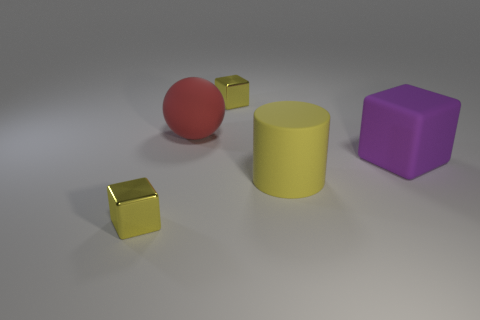Is the tiny yellow object that is behind the big yellow rubber thing made of the same material as the cylinder?
Offer a very short reply. No. How big is the ball that is behind the big purple matte block?
Make the answer very short. Large. There is a tiny metal block that is in front of the large red matte thing; is there a tiny metal cube that is to the right of it?
Keep it short and to the point. Yes. There is a small metal thing in front of the large red rubber thing; does it have the same color as the metallic object that is behind the purple object?
Give a very brief answer. Yes. The rubber cylinder has what color?
Offer a very short reply. Yellow. Is there any other thing that has the same color as the matte cylinder?
Provide a short and direct response. Yes. There is a thing that is in front of the large purple rubber object and on the right side of the rubber ball; what is its color?
Provide a succinct answer. Yellow. Does the rubber object that is right of the yellow cylinder have the same size as the large yellow cylinder?
Make the answer very short. Yes. Are there more blocks on the right side of the yellow matte object than brown rubber things?
Offer a very short reply. Yes. Is the number of tiny shiny things that are in front of the purple rubber object greater than the number of yellow shiny objects on the right side of the yellow cylinder?
Your response must be concise. Yes. 